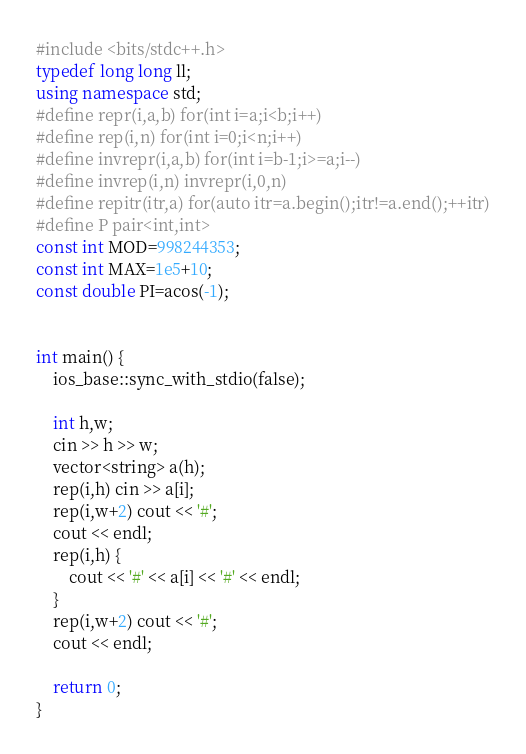<code> <loc_0><loc_0><loc_500><loc_500><_C++_>#include <bits/stdc++.h>
typedef long long ll;
using namespace std;
#define repr(i,a,b) for(int i=a;i<b;i++)
#define rep(i,n) for(int i=0;i<n;i++)
#define invrepr(i,a,b) for(int i=b-1;i>=a;i--)
#define invrep(i,n) invrepr(i,0,n)
#define repitr(itr,a) for(auto itr=a.begin();itr!=a.end();++itr)
#define P pair<int,int>
const int MOD=998244353;
const int MAX=1e5+10;
const double PI=acos(-1);


int main() {
    ios_base::sync_with_stdio(false);

    int h,w; 
    cin >> h >> w;
    vector<string> a(h);
    rep(i,h) cin >> a[i];
    rep(i,w+2) cout << '#';
    cout << endl;
    rep(i,h) {
        cout << '#' << a[i] << '#' << endl;
    }
    rep(i,w+2) cout << '#';
    cout << endl;
     
    return 0;   
}</code> 